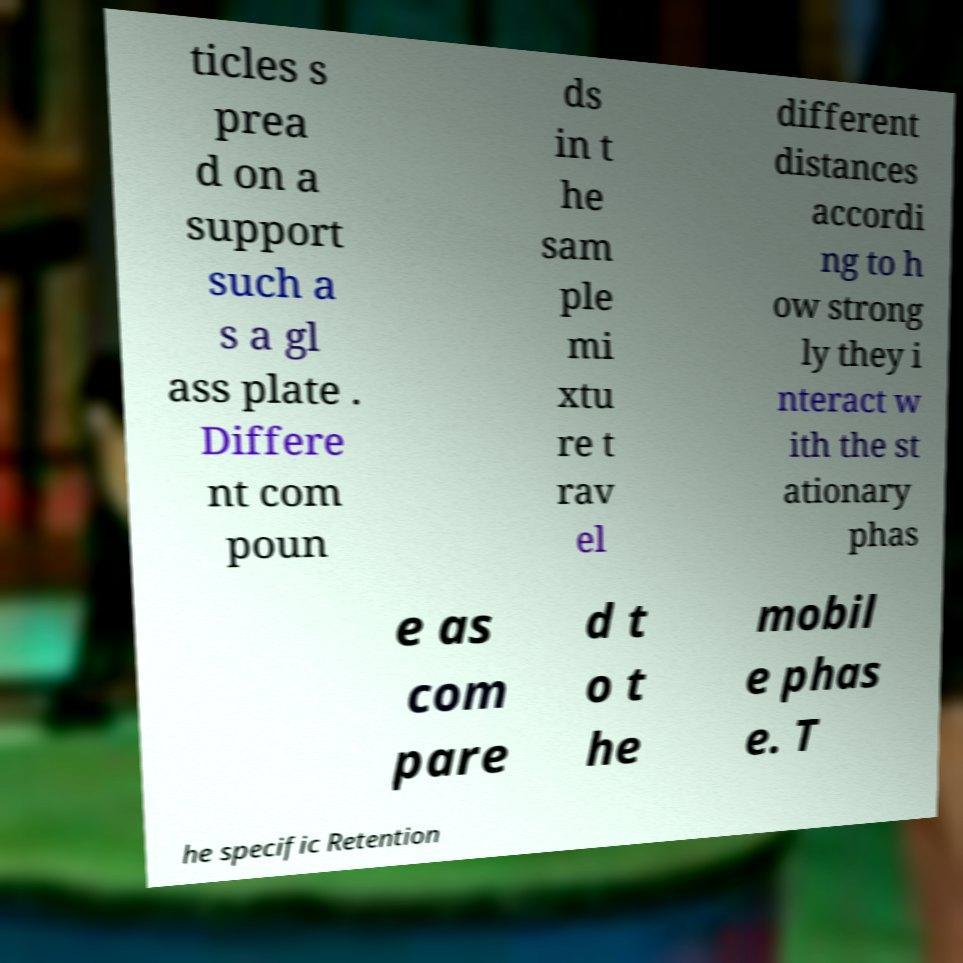Can you read and provide the text displayed in the image?This photo seems to have some interesting text. Can you extract and type it out for me? ticles s prea d on a support such a s a gl ass plate . Differe nt com poun ds in t he sam ple mi xtu re t rav el different distances accordi ng to h ow strong ly they i nteract w ith the st ationary phas e as com pare d t o t he mobil e phas e. T he specific Retention 